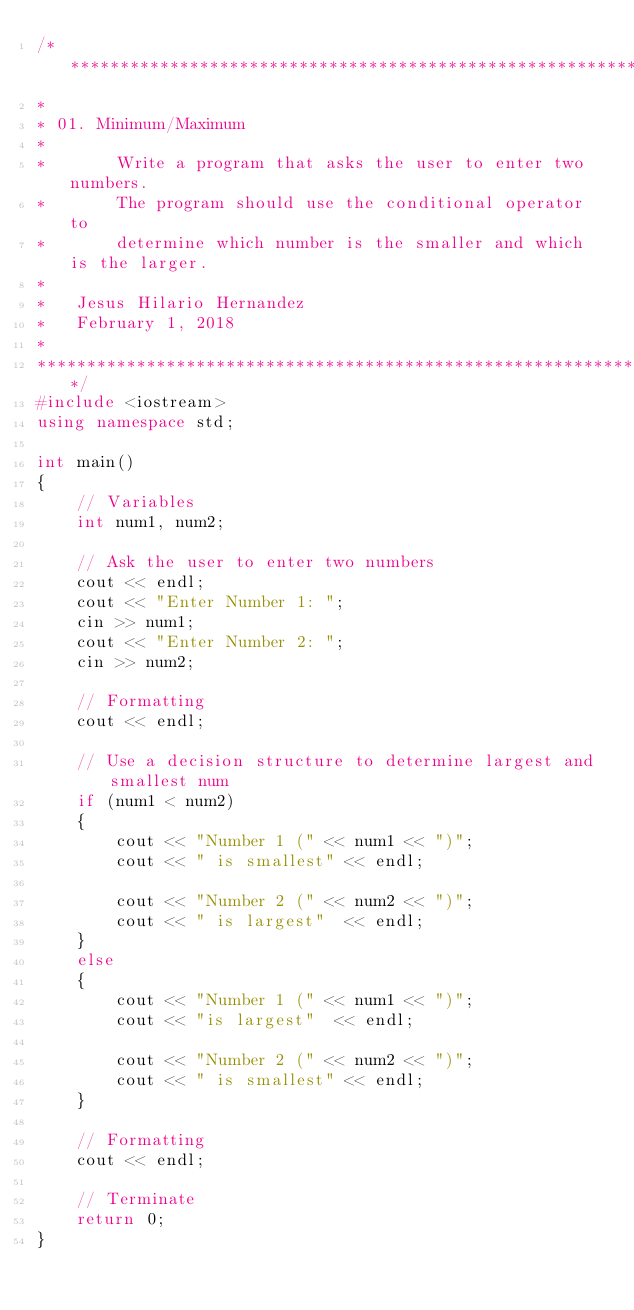Convert code to text. <code><loc_0><loc_0><loc_500><loc_500><_C++_>/********************************************************************
*
*	01. Minimum/Maximum
*
*       Write a program that asks the user to enter two numbers.
*       The program should use the conditional operator to
*       determine which number is the smaller and which is the larger.
*
* 	Jesus Hilario Hernandez
* 	February 1, 2018
*
********************************************************************/
#include <iostream>
using namespace std;

int main()
{
    // Variables
    int num1, num2;

    // Ask the user to enter two numbers
    cout << endl;
    cout << "Enter Number 1: ";
    cin >> num1;
    cout << "Enter Number 2: ";
    cin >> num2;

    // Formatting
    cout << endl;

    // Use a decision structure to determine largest and smallest num
    if (num1 < num2)
    {
        cout << "Number 1 (" << num1 << ")";
        cout << " is smallest" << endl;

        cout << "Number 2 (" << num2 << ")";
        cout << " is largest"  << endl;
    }
    else
    {
        cout << "Number 1 (" << num1 << ")";
        cout << "is largest"  << endl;
        
        cout << "Number 2 (" << num2 << ")";
        cout << " is smallest" << endl;
    }

    // Formatting
    cout << endl;

    // Terminate
    return 0;
}
</code> 